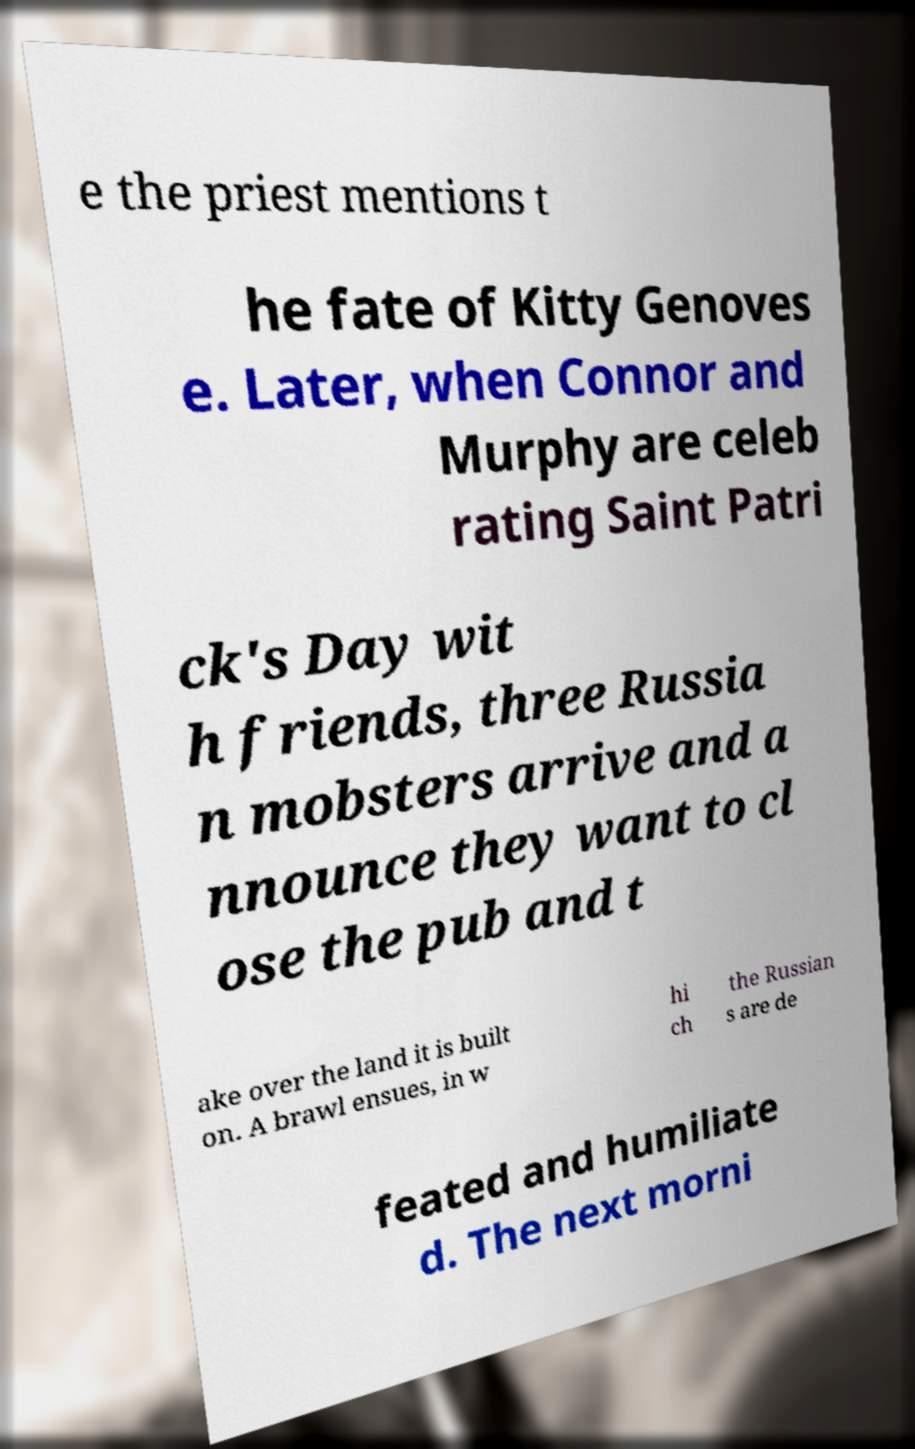Can you read and provide the text displayed in the image?This photo seems to have some interesting text. Can you extract and type it out for me? e the priest mentions t he fate of Kitty Genoves e. Later, when Connor and Murphy are celeb rating Saint Patri ck's Day wit h friends, three Russia n mobsters arrive and a nnounce they want to cl ose the pub and t ake over the land it is built on. A brawl ensues, in w hi ch the Russian s are de feated and humiliate d. The next morni 